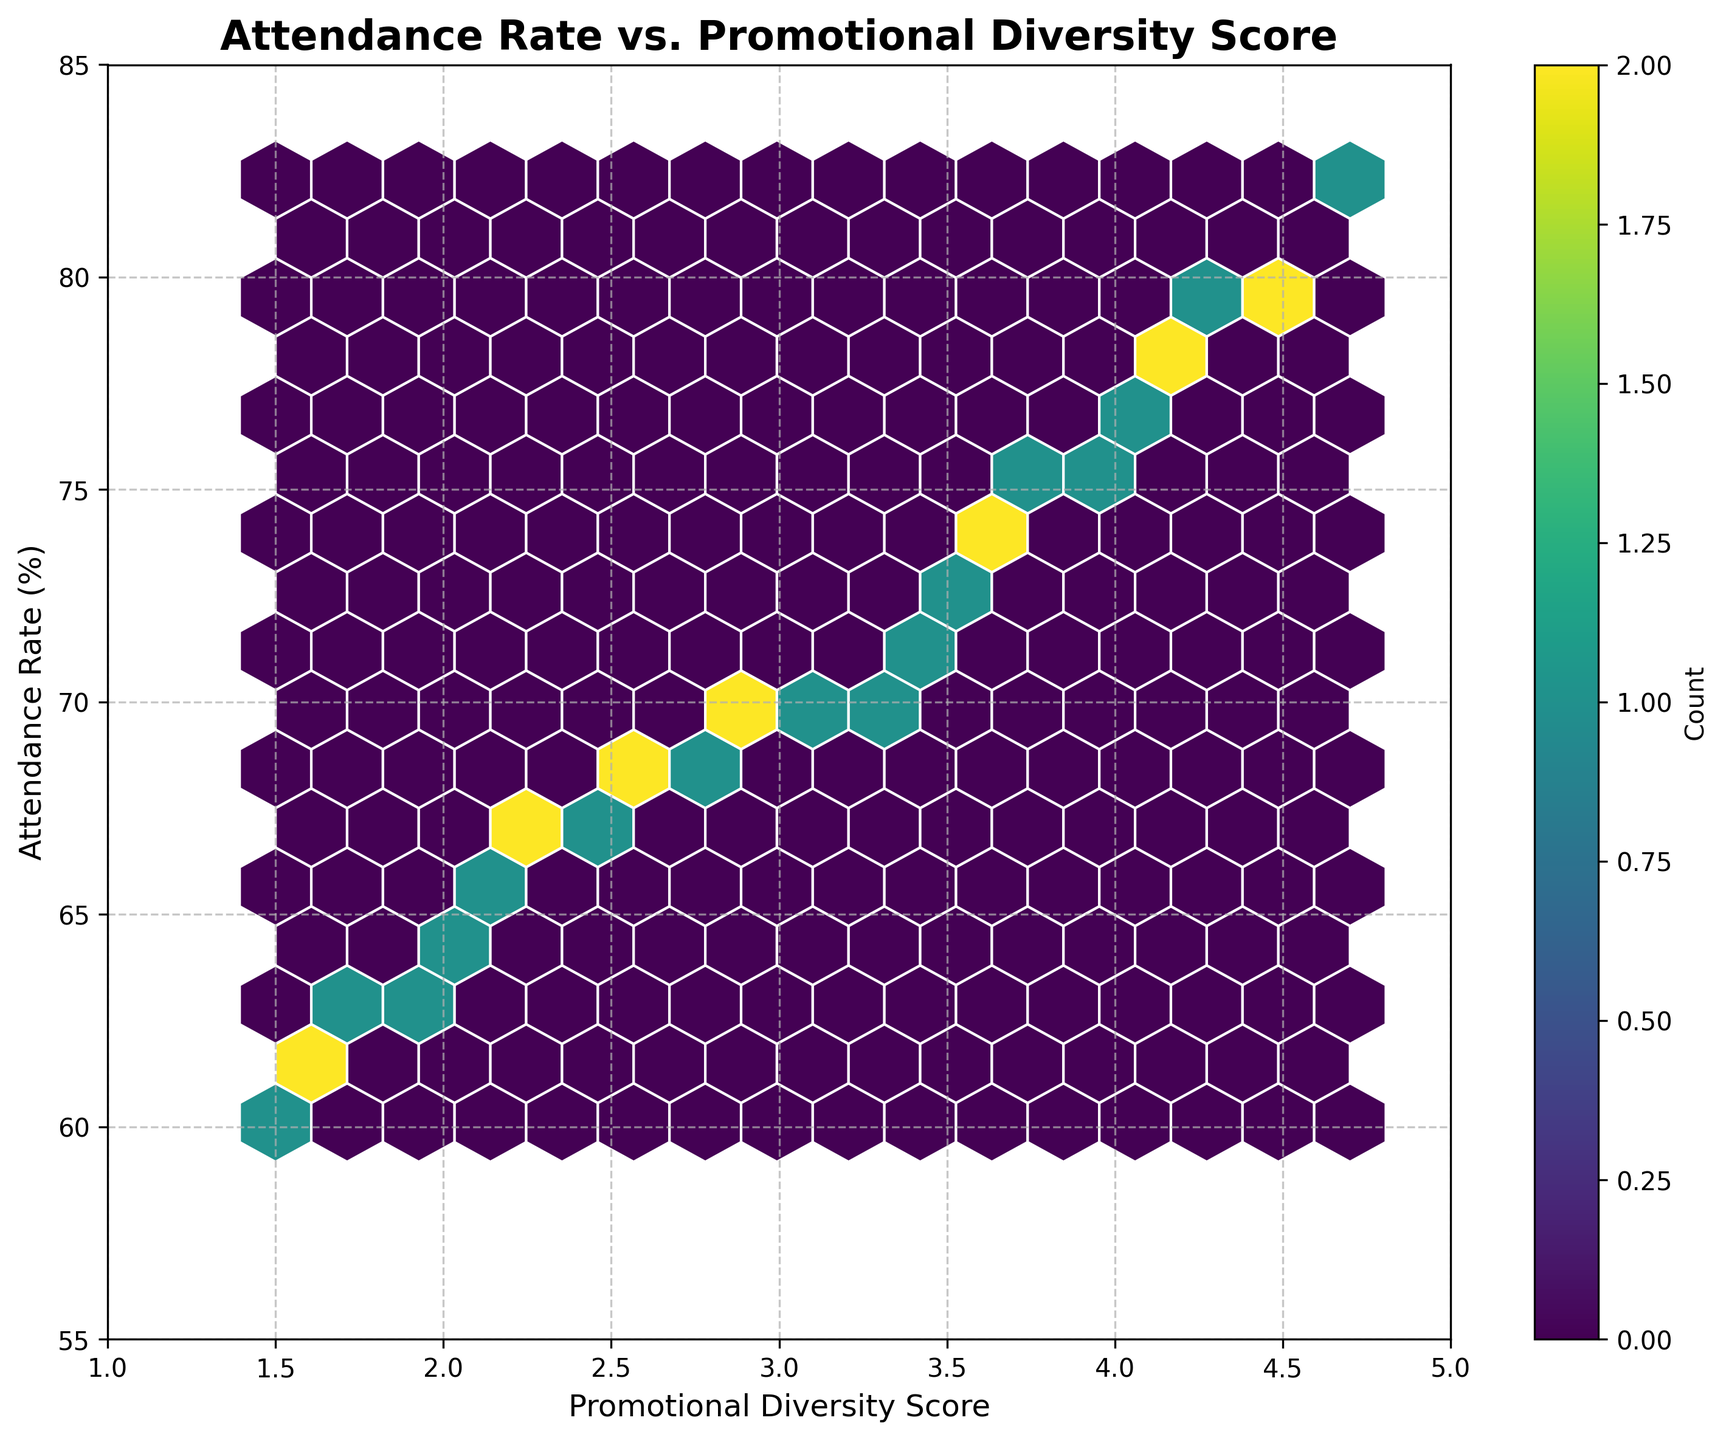What is the title of the hexbin plot? The title of the plot is written at the top center of the figure. It provides context for what the plot represents.
Answer: Attendance Rate vs. Promotional Diversity Score What is the x-axis label of the plot? The x-axis label is located along the horizontal axis, describing what the x-values represent in the plot.
Answer: Promotional Diversity Score What color is used for the hexagons in the plot? The color of the hexagons can be observed directly in the plot. It indicates the density of data points in different regions.
Answer: Various shades of green to yellow (viridis color map) What range does the y-axis cover? The range of the y-axis is indicated by the minimum and maximum values along the vertical axis of the plot.
Answer: 55 to 85 How many data points fall into the highest density hexbin? The hexbin plot includes a color bar that indicates the count of occurrences. The highest density can be identified by the brightest color.
Answer: Specific count from the color bar not given, but visible from the plot's brightest hexbin What is the relationship between promotional diversity score and attendance rate? Observing the overall trend in the plot, one can see if there is a clear directional pattern indicating the relationship between the two variables.
Answer: Positive correlation What is the average attendance rate for promotional diversity scores between 2 and 3? To find this, identify the hexagons corresponding to x-values between 2 and 3 and then average the y-values (attendance rates) of these hexagons.
Answer: Approx. 66.85 Do higher promotional diversity scores generally correspond to higher attendance rates? By observing the pattern of the plot, determine if there is a visible trend of increasing y-values (attendance rates) as x-values (promotional diversity scores) increase.
Answer: Yes What is the promotional diversity score with the lowest attendance rate? Identify the lowest y-value (attendance rate) on the plot and find the corresponding x-value (promotional diversity score).
Answer: 1.5 Which range of promotional diversity scores has the highest concentration of data points? The hexbin plot uses colors to show density. Identify the range of x-values where the most densely colored hexagons are located.
Answer: 3.0 to 4.0 